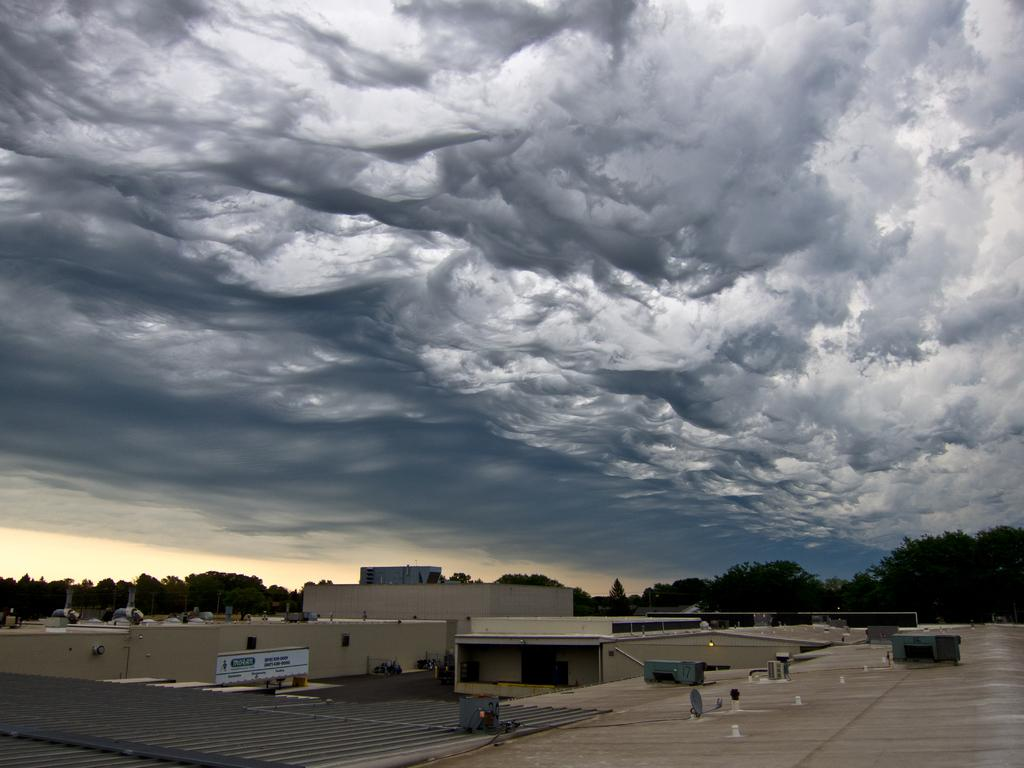What type of structures can be seen in the image? There are buildings in the image. What other natural elements are present in the image? There are trees in the image. What can be seen in the sky in the image? There are clouds in the sky in the image. What type of cake is being served at the thrilling event in the image? There is no cake or thrilling event present in the image; it features buildings, trees, and clouds. 